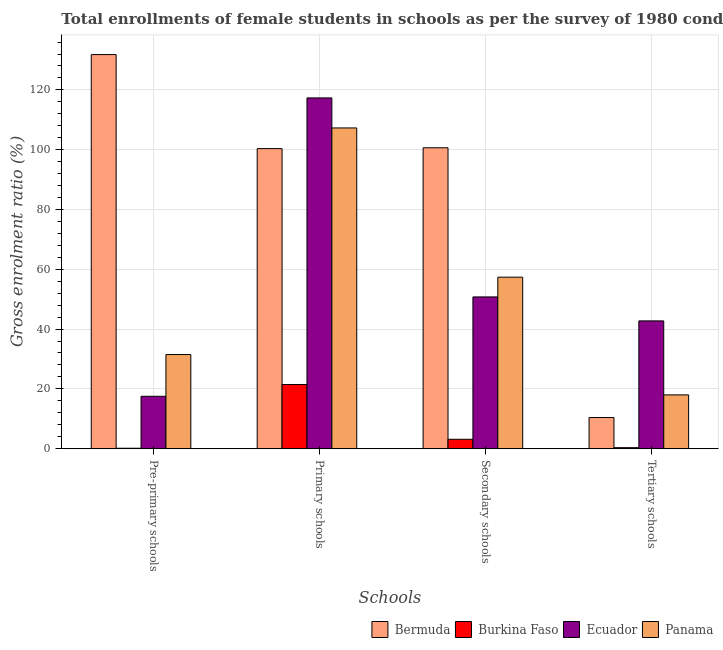How many groups of bars are there?
Offer a terse response. 4. How many bars are there on the 2nd tick from the left?
Give a very brief answer. 4. What is the label of the 3rd group of bars from the left?
Offer a very short reply. Secondary schools. What is the gross enrolment ratio(female) in secondary schools in Panama?
Provide a succinct answer. 57.36. Across all countries, what is the maximum gross enrolment ratio(female) in secondary schools?
Your answer should be compact. 100.64. Across all countries, what is the minimum gross enrolment ratio(female) in pre-primary schools?
Provide a short and direct response. 0.15. In which country was the gross enrolment ratio(female) in pre-primary schools maximum?
Offer a very short reply. Bermuda. In which country was the gross enrolment ratio(female) in pre-primary schools minimum?
Your response must be concise. Burkina Faso. What is the total gross enrolment ratio(female) in pre-primary schools in the graph?
Your response must be concise. 180.96. What is the difference between the gross enrolment ratio(female) in tertiary schools in Bermuda and that in Ecuador?
Provide a succinct answer. -32.32. What is the difference between the gross enrolment ratio(female) in secondary schools in Burkina Faso and the gross enrolment ratio(female) in primary schools in Ecuador?
Your answer should be very brief. -114.17. What is the average gross enrolment ratio(female) in primary schools per country?
Give a very brief answer. 86.6. What is the difference between the gross enrolment ratio(female) in tertiary schools and gross enrolment ratio(female) in primary schools in Ecuador?
Give a very brief answer. -74.57. In how many countries, is the gross enrolment ratio(female) in secondary schools greater than 80 %?
Offer a terse response. 1. What is the ratio of the gross enrolment ratio(female) in primary schools in Bermuda to that in Panama?
Your answer should be very brief. 0.94. Is the gross enrolment ratio(female) in primary schools in Burkina Faso less than that in Panama?
Your answer should be very brief. Yes. What is the difference between the highest and the second highest gross enrolment ratio(female) in pre-primary schools?
Keep it short and to the point. 100.32. What is the difference between the highest and the lowest gross enrolment ratio(female) in secondary schools?
Ensure brevity in your answer.  97.5. In how many countries, is the gross enrolment ratio(female) in secondary schools greater than the average gross enrolment ratio(female) in secondary schools taken over all countries?
Provide a short and direct response. 2. What does the 4th bar from the left in Pre-primary schools represents?
Your response must be concise. Panama. What does the 3rd bar from the right in Primary schools represents?
Your response must be concise. Burkina Faso. Is it the case that in every country, the sum of the gross enrolment ratio(female) in pre-primary schools and gross enrolment ratio(female) in primary schools is greater than the gross enrolment ratio(female) in secondary schools?
Give a very brief answer. Yes. How many bars are there?
Ensure brevity in your answer.  16. Are all the bars in the graph horizontal?
Make the answer very short. No. Does the graph contain any zero values?
Your answer should be compact. No. Does the graph contain grids?
Offer a very short reply. Yes. Where does the legend appear in the graph?
Your answer should be very brief. Bottom right. How are the legend labels stacked?
Make the answer very short. Horizontal. What is the title of the graph?
Provide a succinct answer. Total enrollments of female students in schools as per the survey of 1980 conducted in different countries. Does "Mexico" appear as one of the legend labels in the graph?
Make the answer very short. No. What is the label or title of the X-axis?
Offer a very short reply. Schools. What is the Gross enrolment ratio (%) of Bermuda in Pre-primary schools?
Ensure brevity in your answer.  131.81. What is the Gross enrolment ratio (%) in Burkina Faso in Pre-primary schools?
Offer a very short reply. 0.15. What is the Gross enrolment ratio (%) of Ecuador in Pre-primary schools?
Provide a short and direct response. 17.52. What is the Gross enrolment ratio (%) of Panama in Pre-primary schools?
Provide a succinct answer. 31.48. What is the Gross enrolment ratio (%) of Bermuda in Primary schools?
Make the answer very short. 100.36. What is the Gross enrolment ratio (%) in Burkina Faso in Primary schools?
Offer a terse response. 21.47. What is the Gross enrolment ratio (%) in Ecuador in Primary schools?
Give a very brief answer. 117.31. What is the Gross enrolment ratio (%) of Panama in Primary schools?
Your response must be concise. 107.27. What is the Gross enrolment ratio (%) in Bermuda in Secondary schools?
Make the answer very short. 100.64. What is the Gross enrolment ratio (%) in Burkina Faso in Secondary schools?
Provide a short and direct response. 3.14. What is the Gross enrolment ratio (%) in Ecuador in Secondary schools?
Keep it short and to the point. 50.76. What is the Gross enrolment ratio (%) in Panama in Secondary schools?
Ensure brevity in your answer.  57.36. What is the Gross enrolment ratio (%) of Bermuda in Tertiary schools?
Your answer should be compact. 10.41. What is the Gross enrolment ratio (%) of Burkina Faso in Tertiary schools?
Make the answer very short. 0.33. What is the Gross enrolment ratio (%) of Ecuador in Tertiary schools?
Ensure brevity in your answer.  42.74. What is the Gross enrolment ratio (%) of Panama in Tertiary schools?
Offer a very short reply. 17.98. Across all Schools, what is the maximum Gross enrolment ratio (%) in Bermuda?
Offer a very short reply. 131.81. Across all Schools, what is the maximum Gross enrolment ratio (%) of Burkina Faso?
Your answer should be compact. 21.47. Across all Schools, what is the maximum Gross enrolment ratio (%) of Ecuador?
Provide a short and direct response. 117.31. Across all Schools, what is the maximum Gross enrolment ratio (%) in Panama?
Ensure brevity in your answer.  107.27. Across all Schools, what is the minimum Gross enrolment ratio (%) in Bermuda?
Offer a terse response. 10.41. Across all Schools, what is the minimum Gross enrolment ratio (%) in Burkina Faso?
Your response must be concise. 0.15. Across all Schools, what is the minimum Gross enrolment ratio (%) of Ecuador?
Make the answer very short. 17.52. Across all Schools, what is the minimum Gross enrolment ratio (%) of Panama?
Your answer should be very brief. 17.98. What is the total Gross enrolment ratio (%) of Bermuda in the graph?
Your answer should be very brief. 343.22. What is the total Gross enrolment ratio (%) in Burkina Faso in the graph?
Offer a terse response. 25.09. What is the total Gross enrolment ratio (%) of Ecuador in the graph?
Your answer should be very brief. 228.32. What is the total Gross enrolment ratio (%) of Panama in the graph?
Give a very brief answer. 214.1. What is the difference between the Gross enrolment ratio (%) in Bermuda in Pre-primary schools and that in Primary schools?
Your answer should be very brief. 31.45. What is the difference between the Gross enrolment ratio (%) of Burkina Faso in Pre-primary schools and that in Primary schools?
Provide a succinct answer. -21.32. What is the difference between the Gross enrolment ratio (%) of Ecuador in Pre-primary schools and that in Primary schools?
Provide a short and direct response. -99.79. What is the difference between the Gross enrolment ratio (%) in Panama in Pre-primary schools and that in Primary schools?
Your answer should be compact. -75.79. What is the difference between the Gross enrolment ratio (%) in Bermuda in Pre-primary schools and that in Secondary schools?
Provide a succinct answer. 31.17. What is the difference between the Gross enrolment ratio (%) of Burkina Faso in Pre-primary schools and that in Secondary schools?
Your answer should be compact. -2.99. What is the difference between the Gross enrolment ratio (%) in Ecuador in Pre-primary schools and that in Secondary schools?
Your answer should be very brief. -33.24. What is the difference between the Gross enrolment ratio (%) in Panama in Pre-primary schools and that in Secondary schools?
Provide a succinct answer. -25.87. What is the difference between the Gross enrolment ratio (%) of Bermuda in Pre-primary schools and that in Tertiary schools?
Provide a short and direct response. 121.39. What is the difference between the Gross enrolment ratio (%) in Burkina Faso in Pre-primary schools and that in Tertiary schools?
Your answer should be compact. -0.19. What is the difference between the Gross enrolment ratio (%) of Ecuador in Pre-primary schools and that in Tertiary schools?
Your answer should be very brief. -25.22. What is the difference between the Gross enrolment ratio (%) of Panama in Pre-primary schools and that in Tertiary schools?
Your response must be concise. 13.5. What is the difference between the Gross enrolment ratio (%) of Bermuda in Primary schools and that in Secondary schools?
Keep it short and to the point. -0.28. What is the difference between the Gross enrolment ratio (%) of Burkina Faso in Primary schools and that in Secondary schools?
Provide a short and direct response. 18.33. What is the difference between the Gross enrolment ratio (%) of Ecuador in Primary schools and that in Secondary schools?
Make the answer very short. 66.56. What is the difference between the Gross enrolment ratio (%) in Panama in Primary schools and that in Secondary schools?
Keep it short and to the point. 49.91. What is the difference between the Gross enrolment ratio (%) of Bermuda in Primary schools and that in Tertiary schools?
Give a very brief answer. 89.94. What is the difference between the Gross enrolment ratio (%) in Burkina Faso in Primary schools and that in Tertiary schools?
Ensure brevity in your answer.  21.13. What is the difference between the Gross enrolment ratio (%) of Ecuador in Primary schools and that in Tertiary schools?
Make the answer very short. 74.57. What is the difference between the Gross enrolment ratio (%) of Panama in Primary schools and that in Tertiary schools?
Your answer should be very brief. 89.29. What is the difference between the Gross enrolment ratio (%) in Bermuda in Secondary schools and that in Tertiary schools?
Provide a succinct answer. 90.23. What is the difference between the Gross enrolment ratio (%) of Burkina Faso in Secondary schools and that in Tertiary schools?
Provide a short and direct response. 2.8. What is the difference between the Gross enrolment ratio (%) in Ecuador in Secondary schools and that in Tertiary schools?
Make the answer very short. 8.02. What is the difference between the Gross enrolment ratio (%) in Panama in Secondary schools and that in Tertiary schools?
Offer a very short reply. 39.37. What is the difference between the Gross enrolment ratio (%) in Bermuda in Pre-primary schools and the Gross enrolment ratio (%) in Burkina Faso in Primary schools?
Offer a terse response. 110.34. What is the difference between the Gross enrolment ratio (%) of Bermuda in Pre-primary schools and the Gross enrolment ratio (%) of Ecuador in Primary schools?
Keep it short and to the point. 14.5. What is the difference between the Gross enrolment ratio (%) in Bermuda in Pre-primary schools and the Gross enrolment ratio (%) in Panama in Primary schools?
Provide a succinct answer. 24.54. What is the difference between the Gross enrolment ratio (%) of Burkina Faso in Pre-primary schools and the Gross enrolment ratio (%) of Ecuador in Primary schools?
Offer a terse response. -117.17. What is the difference between the Gross enrolment ratio (%) of Burkina Faso in Pre-primary schools and the Gross enrolment ratio (%) of Panama in Primary schools?
Keep it short and to the point. -107.12. What is the difference between the Gross enrolment ratio (%) in Ecuador in Pre-primary schools and the Gross enrolment ratio (%) in Panama in Primary schools?
Your answer should be very brief. -89.75. What is the difference between the Gross enrolment ratio (%) in Bermuda in Pre-primary schools and the Gross enrolment ratio (%) in Burkina Faso in Secondary schools?
Provide a succinct answer. 128.67. What is the difference between the Gross enrolment ratio (%) in Bermuda in Pre-primary schools and the Gross enrolment ratio (%) in Ecuador in Secondary schools?
Provide a short and direct response. 81.05. What is the difference between the Gross enrolment ratio (%) of Bermuda in Pre-primary schools and the Gross enrolment ratio (%) of Panama in Secondary schools?
Your answer should be very brief. 74.45. What is the difference between the Gross enrolment ratio (%) in Burkina Faso in Pre-primary schools and the Gross enrolment ratio (%) in Ecuador in Secondary schools?
Give a very brief answer. -50.61. What is the difference between the Gross enrolment ratio (%) of Burkina Faso in Pre-primary schools and the Gross enrolment ratio (%) of Panama in Secondary schools?
Your response must be concise. -57.21. What is the difference between the Gross enrolment ratio (%) of Ecuador in Pre-primary schools and the Gross enrolment ratio (%) of Panama in Secondary schools?
Offer a very short reply. -39.84. What is the difference between the Gross enrolment ratio (%) in Bermuda in Pre-primary schools and the Gross enrolment ratio (%) in Burkina Faso in Tertiary schools?
Ensure brevity in your answer.  131.47. What is the difference between the Gross enrolment ratio (%) in Bermuda in Pre-primary schools and the Gross enrolment ratio (%) in Ecuador in Tertiary schools?
Offer a terse response. 89.07. What is the difference between the Gross enrolment ratio (%) in Bermuda in Pre-primary schools and the Gross enrolment ratio (%) in Panama in Tertiary schools?
Offer a terse response. 113.82. What is the difference between the Gross enrolment ratio (%) in Burkina Faso in Pre-primary schools and the Gross enrolment ratio (%) in Ecuador in Tertiary schools?
Provide a succinct answer. -42.59. What is the difference between the Gross enrolment ratio (%) of Burkina Faso in Pre-primary schools and the Gross enrolment ratio (%) of Panama in Tertiary schools?
Provide a succinct answer. -17.84. What is the difference between the Gross enrolment ratio (%) of Ecuador in Pre-primary schools and the Gross enrolment ratio (%) of Panama in Tertiary schools?
Provide a short and direct response. -0.47. What is the difference between the Gross enrolment ratio (%) in Bermuda in Primary schools and the Gross enrolment ratio (%) in Burkina Faso in Secondary schools?
Give a very brief answer. 97.22. What is the difference between the Gross enrolment ratio (%) of Bermuda in Primary schools and the Gross enrolment ratio (%) of Ecuador in Secondary schools?
Provide a short and direct response. 49.6. What is the difference between the Gross enrolment ratio (%) of Bermuda in Primary schools and the Gross enrolment ratio (%) of Panama in Secondary schools?
Make the answer very short. 43. What is the difference between the Gross enrolment ratio (%) in Burkina Faso in Primary schools and the Gross enrolment ratio (%) in Ecuador in Secondary schools?
Your response must be concise. -29.29. What is the difference between the Gross enrolment ratio (%) in Burkina Faso in Primary schools and the Gross enrolment ratio (%) in Panama in Secondary schools?
Your answer should be compact. -35.89. What is the difference between the Gross enrolment ratio (%) of Ecuador in Primary schools and the Gross enrolment ratio (%) of Panama in Secondary schools?
Offer a terse response. 59.95. What is the difference between the Gross enrolment ratio (%) in Bermuda in Primary schools and the Gross enrolment ratio (%) in Burkina Faso in Tertiary schools?
Provide a short and direct response. 100.02. What is the difference between the Gross enrolment ratio (%) in Bermuda in Primary schools and the Gross enrolment ratio (%) in Ecuador in Tertiary schools?
Your answer should be compact. 57.62. What is the difference between the Gross enrolment ratio (%) of Bermuda in Primary schools and the Gross enrolment ratio (%) of Panama in Tertiary schools?
Your answer should be very brief. 82.37. What is the difference between the Gross enrolment ratio (%) of Burkina Faso in Primary schools and the Gross enrolment ratio (%) of Ecuador in Tertiary schools?
Offer a very short reply. -21.27. What is the difference between the Gross enrolment ratio (%) in Burkina Faso in Primary schools and the Gross enrolment ratio (%) in Panama in Tertiary schools?
Keep it short and to the point. 3.48. What is the difference between the Gross enrolment ratio (%) of Ecuador in Primary schools and the Gross enrolment ratio (%) of Panama in Tertiary schools?
Provide a short and direct response. 99.33. What is the difference between the Gross enrolment ratio (%) in Bermuda in Secondary schools and the Gross enrolment ratio (%) in Burkina Faso in Tertiary schools?
Give a very brief answer. 100.31. What is the difference between the Gross enrolment ratio (%) of Bermuda in Secondary schools and the Gross enrolment ratio (%) of Ecuador in Tertiary schools?
Provide a short and direct response. 57.9. What is the difference between the Gross enrolment ratio (%) of Bermuda in Secondary schools and the Gross enrolment ratio (%) of Panama in Tertiary schools?
Keep it short and to the point. 82.66. What is the difference between the Gross enrolment ratio (%) in Burkina Faso in Secondary schools and the Gross enrolment ratio (%) in Ecuador in Tertiary schools?
Give a very brief answer. -39.6. What is the difference between the Gross enrolment ratio (%) of Burkina Faso in Secondary schools and the Gross enrolment ratio (%) of Panama in Tertiary schools?
Ensure brevity in your answer.  -14.85. What is the difference between the Gross enrolment ratio (%) in Ecuador in Secondary schools and the Gross enrolment ratio (%) in Panama in Tertiary schools?
Offer a very short reply. 32.77. What is the average Gross enrolment ratio (%) of Bermuda per Schools?
Make the answer very short. 85.81. What is the average Gross enrolment ratio (%) of Burkina Faso per Schools?
Keep it short and to the point. 6.27. What is the average Gross enrolment ratio (%) in Ecuador per Schools?
Provide a succinct answer. 57.08. What is the average Gross enrolment ratio (%) of Panama per Schools?
Your response must be concise. 53.52. What is the difference between the Gross enrolment ratio (%) of Bermuda and Gross enrolment ratio (%) of Burkina Faso in Pre-primary schools?
Offer a terse response. 131.66. What is the difference between the Gross enrolment ratio (%) in Bermuda and Gross enrolment ratio (%) in Ecuador in Pre-primary schools?
Make the answer very short. 114.29. What is the difference between the Gross enrolment ratio (%) of Bermuda and Gross enrolment ratio (%) of Panama in Pre-primary schools?
Offer a very short reply. 100.32. What is the difference between the Gross enrolment ratio (%) of Burkina Faso and Gross enrolment ratio (%) of Ecuador in Pre-primary schools?
Provide a short and direct response. -17.37. What is the difference between the Gross enrolment ratio (%) of Burkina Faso and Gross enrolment ratio (%) of Panama in Pre-primary schools?
Keep it short and to the point. -31.34. What is the difference between the Gross enrolment ratio (%) in Ecuador and Gross enrolment ratio (%) in Panama in Pre-primary schools?
Your response must be concise. -13.97. What is the difference between the Gross enrolment ratio (%) in Bermuda and Gross enrolment ratio (%) in Burkina Faso in Primary schools?
Offer a very short reply. 78.89. What is the difference between the Gross enrolment ratio (%) of Bermuda and Gross enrolment ratio (%) of Ecuador in Primary schools?
Your answer should be compact. -16.95. What is the difference between the Gross enrolment ratio (%) of Bermuda and Gross enrolment ratio (%) of Panama in Primary schools?
Offer a terse response. -6.91. What is the difference between the Gross enrolment ratio (%) of Burkina Faso and Gross enrolment ratio (%) of Ecuador in Primary schools?
Offer a terse response. -95.85. What is the difference between the Gross enrolment ratio (%) of Burkina Faso and Gross enrolment ratio (%) of Panama in Primary schools?
Offer a terse response. -85.8. What is the difference between the Gross enrolment ratio (%) in Ecuador and Gross enrolment ratio (%) in Panama in Primary schools?
Offer a terse response. 10.04. What is the difference between the Gross enrolment ratio (%) of Bermuda and Gross enrolment ratio (%) of Burkina Faso in Secondary schools?
Offer a very short reply. 97.5. What is the difference between the Gross enrolment ratio (%) of Bermuda and Gross enrolment ratio (%) of Ecuador in Secondary schools?
Provide a short and direct response. 49.89. What is the difference between the Gross enrolment ratio (%) in Bermuda and Gross enrolment ratio (%) in Panama in Secondary schools?
Your answer should be very brief. 43.28. What is the difference between the Gross enrolment ratio (%) of Burkina Faso and Gross enrolment ratio (%) of Ecuador in Secondary schools?
Your answer should be compact. -47.62. What is the difference between the Gross enrolment ratio (%) of Burkina Faso and Gross enrolment ratio (%) of Panama in Secondary schools?
Make the answer very short. -54.22. What is the difference between the Gross enrolment ratio (%) in Ecuador and Gross enrolment ratio (%) in Panama in Secondary schools?
Your answer should be compact. -6.6. What is the difference between the Gross enrolment ratio (%) in Bermuda and Gross enrolment ratio (%) in Burkina Faso in Tertiary schools?
Give a very brief answer. 10.08. What is the difference between the Gross enrolment ratio (%) of Bermuda and Gross enrolment ratio (%) of Ecuador in Tertiary schools?
Provide a succinct answer. -32.32. What is the difference between the Gross enrolment ratio (%) of Bermuda and Gross enrolment ratio (%) of Panama in Tertiary schools?
Provide a succinct answer. -7.57. What is the difference between the Gross enrolment ratio (%) in Burkina Faso and Gross enrolment ratio (%) in Ecuador in Tertiary schools?
Your answer should be compact. -42.4. What is the difference between the Gross enrolment ratio (%) of Burkina Faso and Gross enrolment ratio (%) of Panama in Tertiary schools?
Your response must be concise. -17.65. What is the difference between the Gross enrolment ratio (%) of Ecuador and Gross enrolment ratio (%) of Panama in Tertiary schools?
Provide a succinct answer. 24.75. What is the ratio of the Gross enrolment ratio (%) in Bermuda in Pre-primary schools to that in Primary schools?
Provide a succinct answer. 1.31. What is the ratio of the Gross enrolment ratio (%) of Burkina Faso in Pre-primary schools to that in Primary schools?
Your response must be concise. 0.01. What is the ratio of the Gross enrolment ratio (%) in Ecuador in Pre-primary schools to that in Primary schools?
Your answer should be very brief. 0.15. What is the ratio of the Gross enrolment ratio (%) of Panama in Pre-primary schools to that in Primary schools?
Provide a succinct answer. 0.29. What is the ratio of the Gross enrolment ratio (%) in Bermuda in Pre-primary schools to that in Secondary schools?
Make the answer very short. 1.31. What is the ratio of the Gross enrolment ratio (%) in Burkina Faso in Pre-primary schools to that in Secondary schools?
Offer a terse response. 0.05. What is the ratio of the Gross enrolment ratio (%) in Ecuador in Pre-primary schools to that in Secondary schools?
Provide a short and direct response. 0.35. What is the ratio of the Gross enrolment ratio (%) of Panama in Pre-primary schools to that in Secondary schools?
Your answer should be compact. 0.55. What is the ratio of the Gross enrolment ratio (%) of Bermuda in Pre-primary schools to that in Tertiary schools?
Offer a terse response. 12.66. What is the ratio of the Gross enrolment ratio (%) of Burkina Faso in Pre-primary schools to that in Tertiary schools?
Your response must be concise. 0.44. What is the ratio of the Gross enrolment ratio (%) in Ecuador in Pre-primary schools to that in Tertiary schools?
Make the answer very short. 0.41. What is the ratio of the Gross enrolment ratio (%) of Panama in Pre-primary schools to that in Tertiary schools?
Ensure brevity in your answer.  1.75. What is the ratio of the Gross enrolment ratio (%) in Bermuda in Primary schools to that in Secondary schools?
Make the answer very short. 1. What is the ratio of the Gross enrolment ratio (%) in Burkina Faso in Primary schools to that in Secondary schools?
Your response must be concise. 6.84. What is the ratio of the Gross enrolment ratio (%) in Ecuador in Primary schools to that in Secondary schools?
Your answer should be compact. 2.31. What is the ratio of the Gross enrolment ratio (%) of Panama in Primary schools to that in Secondary schools?
Provide a short and direct response. 1.87. What is the ratio of the Gross enrolment ratio (%) of Bermuda in Primary schools to that in Tertiary schools?
Keep it short and to the point. 9.64. What is the ratio of the Gross enrolment ratio (%) of Burkina Faso in Primary schools to that in Tertiary schools?
Your answer should be very brief. 64.36. What is the ratio of the Gross enrolment ratio (%) of Ecuador in Primary schools to that in Tertiary schools?
Your response must be concise. 2.74. What is the ratio of the Gross enrolment ratio (%) in Panama in Primary schools to that in Tertiary schools?
Ensure brevity in your answer.  5.96. What is the ratio of the Gross enrolment ratio (%) of Bermuda in Secondary schools to that in Tertiary schools?
Provide a short and direct response. 9.66. What is the ratio of the Gross enrolment ratio (%) of Burkina Faso in Secondary schools to that in Tertiary schools?
Ensure brevity in your answer.  9.41. What is the ratio of the Gross enrolment ratio (%) in Ecuador in Secondary schools to that in Tertiary schools?
Offer a terse response. 1.19. What is the ratio of the Gross enrolment ratio (%) in Panama in Secondary schools to that in Tertiary schools?
Give a very brief answer. 3.19. What is the difference between the highest and the second highest Gross enrolment ratio (%) of Bermuda?
Give a very brief answer. 31.17. What is the difference between the highest and the second highest Gross enrolment ratio (%) in Burkina Faso?
Ensure brevity in your answer.  18.33. What is the difference between the highest and the second highest Gross enrolment ratio (%) in Ecuador?
Make the answer very short. 66.56. What is the difference between the highest and the second highest Gross enrolment ratio (%) of Panama?
Your answer should be compact. 49.91. What is the difference between the highest and the lowest Gross enrolment ratio (%) in Bermuda?
Provide a short and direct response. 121.39. What is the difference between the highest and the lowest Gross enrolment ratio (%) of Burkina Faso?
Give a very brief answer. 21.32. What is the difference between the highest and the lowest Gross enrolment ratio (%) in Ecuador?
Keep it short and to the point. 99.79. What is the difference between the highest and the lowest Gross enrolment ratio (%) in Panama?
Your response must be concise. 89.29. 